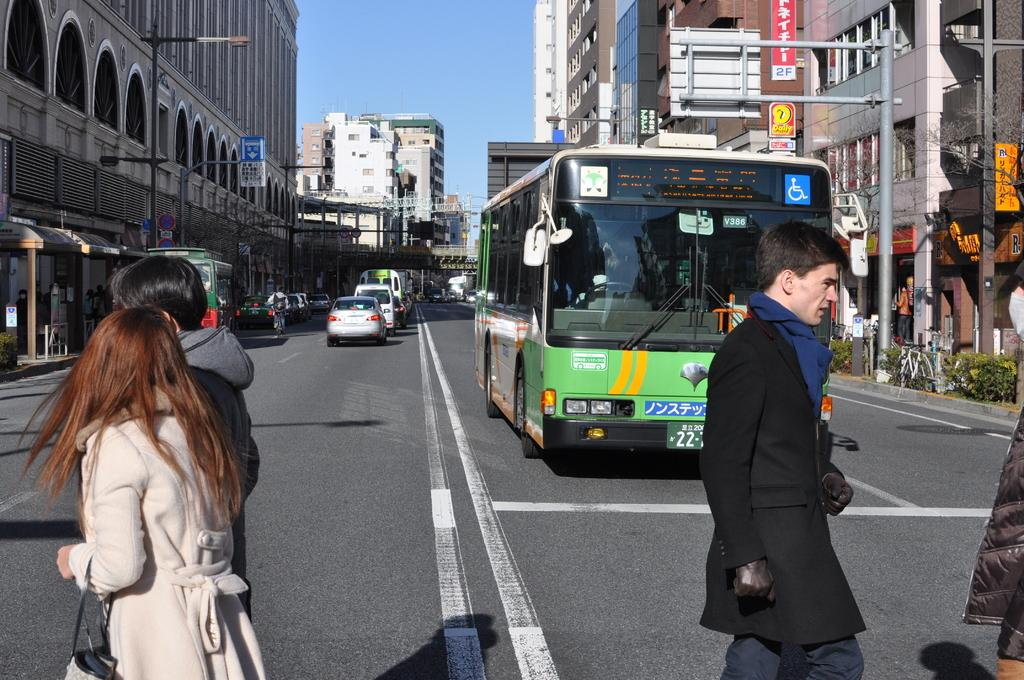<image>
Offer a succinct explanation of the picture presented. A bus is designated with number V386 in the window. 